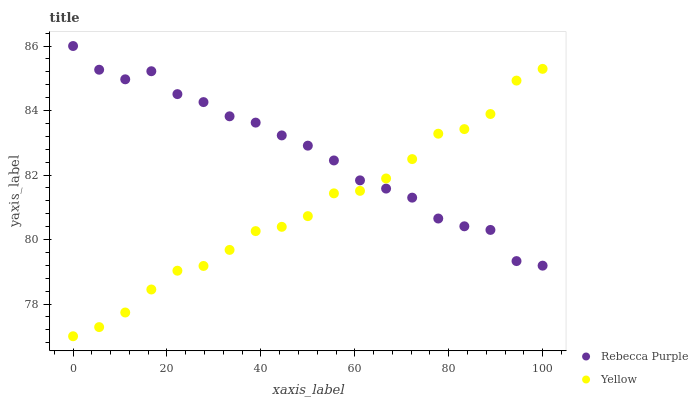Does Yellow have the minimum area under the curve?
Answer yes or no. Yes. Does Rebecca Purple have the maximum area under the curve?
Answer yes or no. Yes. Does Yellow have the maximum area under the curve?
Answer yes or no. No. Is Yellow the smoothest?
Answer yes or no. Yes. Is Rebecca Purple the roughest?
Answer yes or no. Yes. Is Yellow the roughest?
Answer yes or no. No. Does Yellow have the lowest value?
Answer yes or no. Yes. Does Rebecca Purple have the highest value?
Answer yes or no. Yes. Does Yellow have the highest value?
Answer yes or no. No. Does Yellow intersect Rebecca Purple?
Answer yes or no. Yes. Is Yellow less than Rebecca Purple?
Answer yes or no. No. Is Yellow greater than Rebecca Purple?
Answer yes or no. No. 